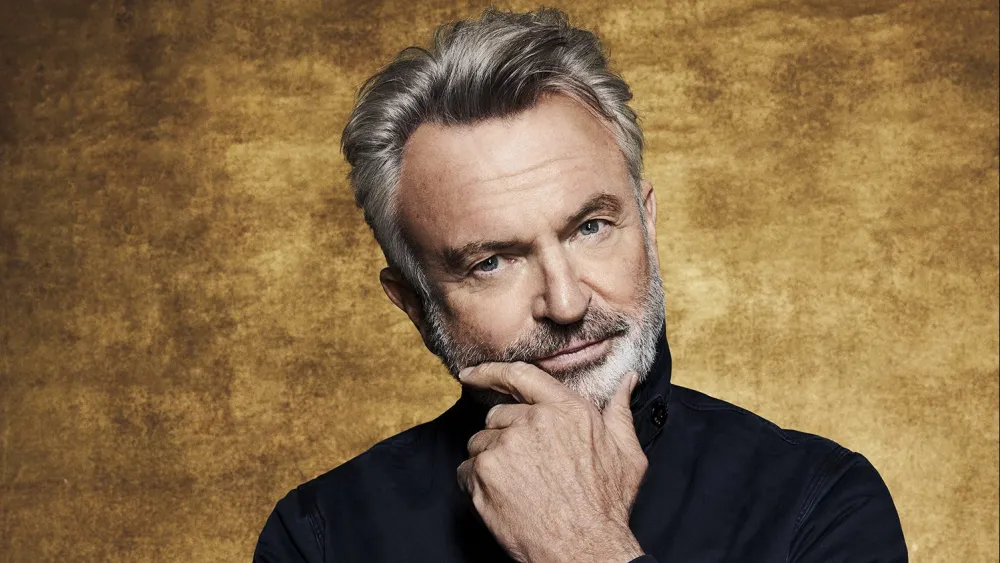What can you tell me about the setting and background of this image? The background of the image features a textured gold surface that adds a warm and elegant tone to the overall composition. The gold hue contrasts beautifully with the subject’s black shirt, making him stand out. The lighting appears soft and even, ensuring that the features of the gentleman are clearly visible without harsh shadows. This combination of elements creates a sophisticated and contemplative atmosphere, highlighting the thoughtful expression and pose of the subject. 